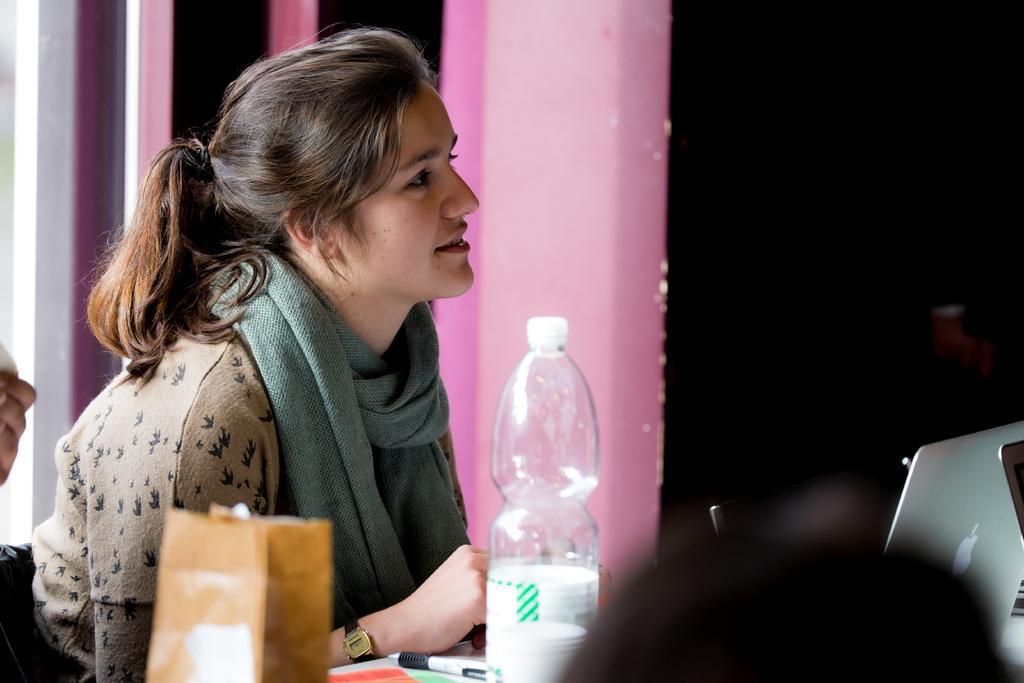Could you give a brief overview of what you see in this image? In the image there is a lady. She is wearing a scarf. At the bottom there is a table and we can see bottle, pen and a packet placed on the table. In the background there is a curtain. 